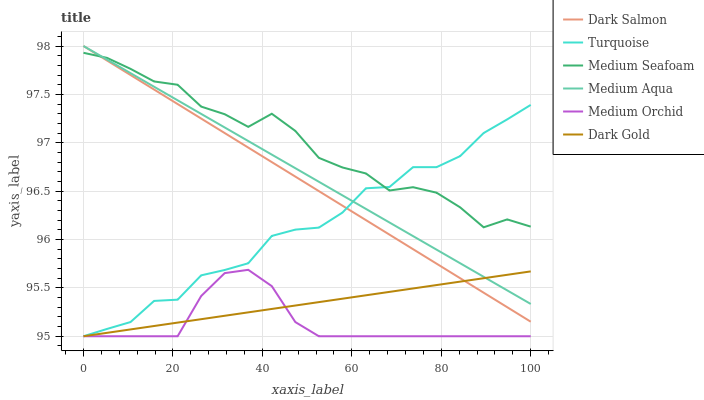Does Medium Orchid have the minimum area under the curve?
Answer yes or no. Yes. Does Medium Seafoam have the maximum area under the curve?
Answer yes or no. Yes. Does Dark Gold have the minimum area under the curve?
Answer yes or no. No. Does Dark Gold have the maximum area under the curve?
Answer yes or no. No. Is Medium Aqua the smoothest?
Answer yes or no. Yes. Is Turquoise the roughest?
Answer yes or no. Yes. Is Dark Gold the smoothest?
Answer yes or no. No. Is Dark Gold the roughest?
Answer yes or no. No. Does Turquoise have the lowest value?
Answer yes or no. Yes. Does Dark Salmon have the lowest value?
Answer yes or no. No. Does Medium Aqua have the highest value?
Answer yes or no. Yes. Does Medium Orchid have the highest value?
Answer yes or no. No. Is Medium Orchid less than Medium Aqua?
Answer yes or no. Yes. Is Medium Seafoam greater than Medium Orchid?
Answer yes or no. Yes. Does Turquoise intersect Dark Gold?
Answer yes or no. Yes. Is Turquoise less than Dark Gold?
Answer yes or no. No. Is Turquoise greater than Dark Gold?
Answer yes or no. No. Does Medium Orchid intersect Medium Aqua?
Answer yes or no. No. 